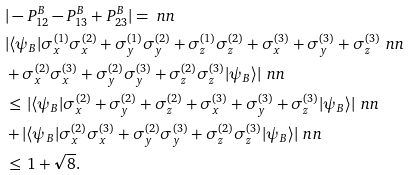<formula> <loc_0><loc_0><loc_500><loc_500>& | - P ^ { B } _ { 1 2 } - P ^ { B } _ { 1 3 } + P ^ { B } _ { 2 3 } | = \ n n \\ & | \langle \psi _ { B } | \sigma ^ { ( 1 ) } _ { x } \sigma ^ { ( 2 ) } _ { x } + \sigma ^ { ( 1 ) } _ { y } \sigma ^ { ( 2 ) } _ { y } + \sigma ^ { ( 1 ) } _ { z } \sigma ^ { ( 2 ) } _ { z } + \sigma ^ { ( 3 ) } _ { x } + \sigma ^ { ( 3 ) } _ { y } + \sigma ^ { ( 3 ) } _ { z } \ n n \\ & + \sigma ^ { ( 2 ) } _ { x } \sigma ^ { ( 3 ) } _ { x } + \sigma ^ { ( 2 ) } _ { y } \sigma ^ { ( 3 ) } _ { y } + \sigma ^ { ( 2 ) } _ { z } \sigma ^ { ( 3 ) } _ { z } | \psi _ { B } \rangle | \ n n \\ & \leq \, | \langle \psi _ { B } | \sigma ^ { ( 2 ) } _ { x } + \sigma ^ { ( 2 ) } _ { y } + \sigma ^ { ( 2 ) } _ { z } + \sigma ^ { ( 3 ) } _ { x } + \sigma ^ { ( 3 ) } _ { y } + \sigma ^ { ( 3 ) } _ { z } | \psi _ { B } \rangle | \ n n \\ & + | \langle \psi _ { B } | \sigma ^ { ( 2 ) } _ { x } \sigma ^ { ( 3 ) } _ { x } + \sigma ^ { ( 2 ) } _ { y } \sigma ^ { ( 3 ) } _ { y } + \sigma ^ { ( 2 ) } _ { z } \sigma ^ { ( 3 ) } _ { z } | \psi _ { B } \rangle | \ n n \\ & \leq \, 1 + \sqrt { 8 } .</formula> 